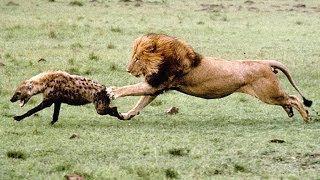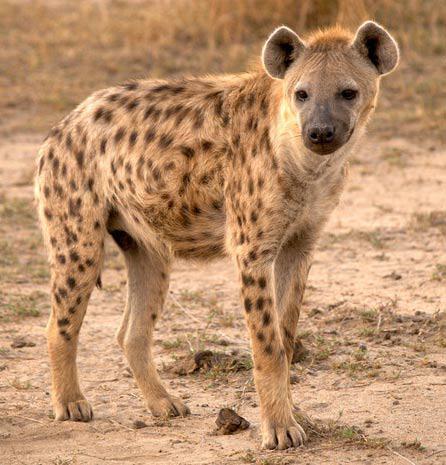The first image is the image on the left, the second image is the image on the right. For the images displayed, is the sentence "One of the images contains a hyena eating a dead animal." factually correct? Answer yes or no. No. 